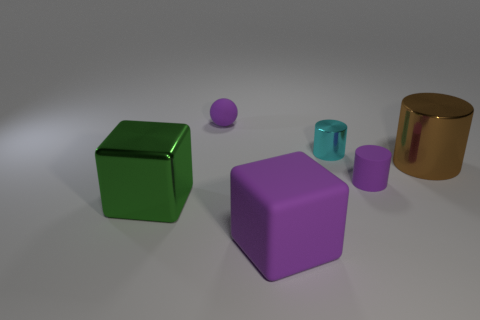Subtract all matte cylinders. How many cylinders are left? 2 Add 4 purple things. How many objects exist? 10 Subtract all blocks. How many objects are left? 4 Subtract 0 brown cubes. How many objects are left? 6 Subtract all red spheres. Subtract all purple cubes. How many spheres are left? 1 Subtract all big purple matte things. Subtract all blocks. How many objects are left? 3 Add 2 big rubber blocks. How many big rubber blocks are left? 3 Add 6 gray cubes. How many gray cubes exist? 6 